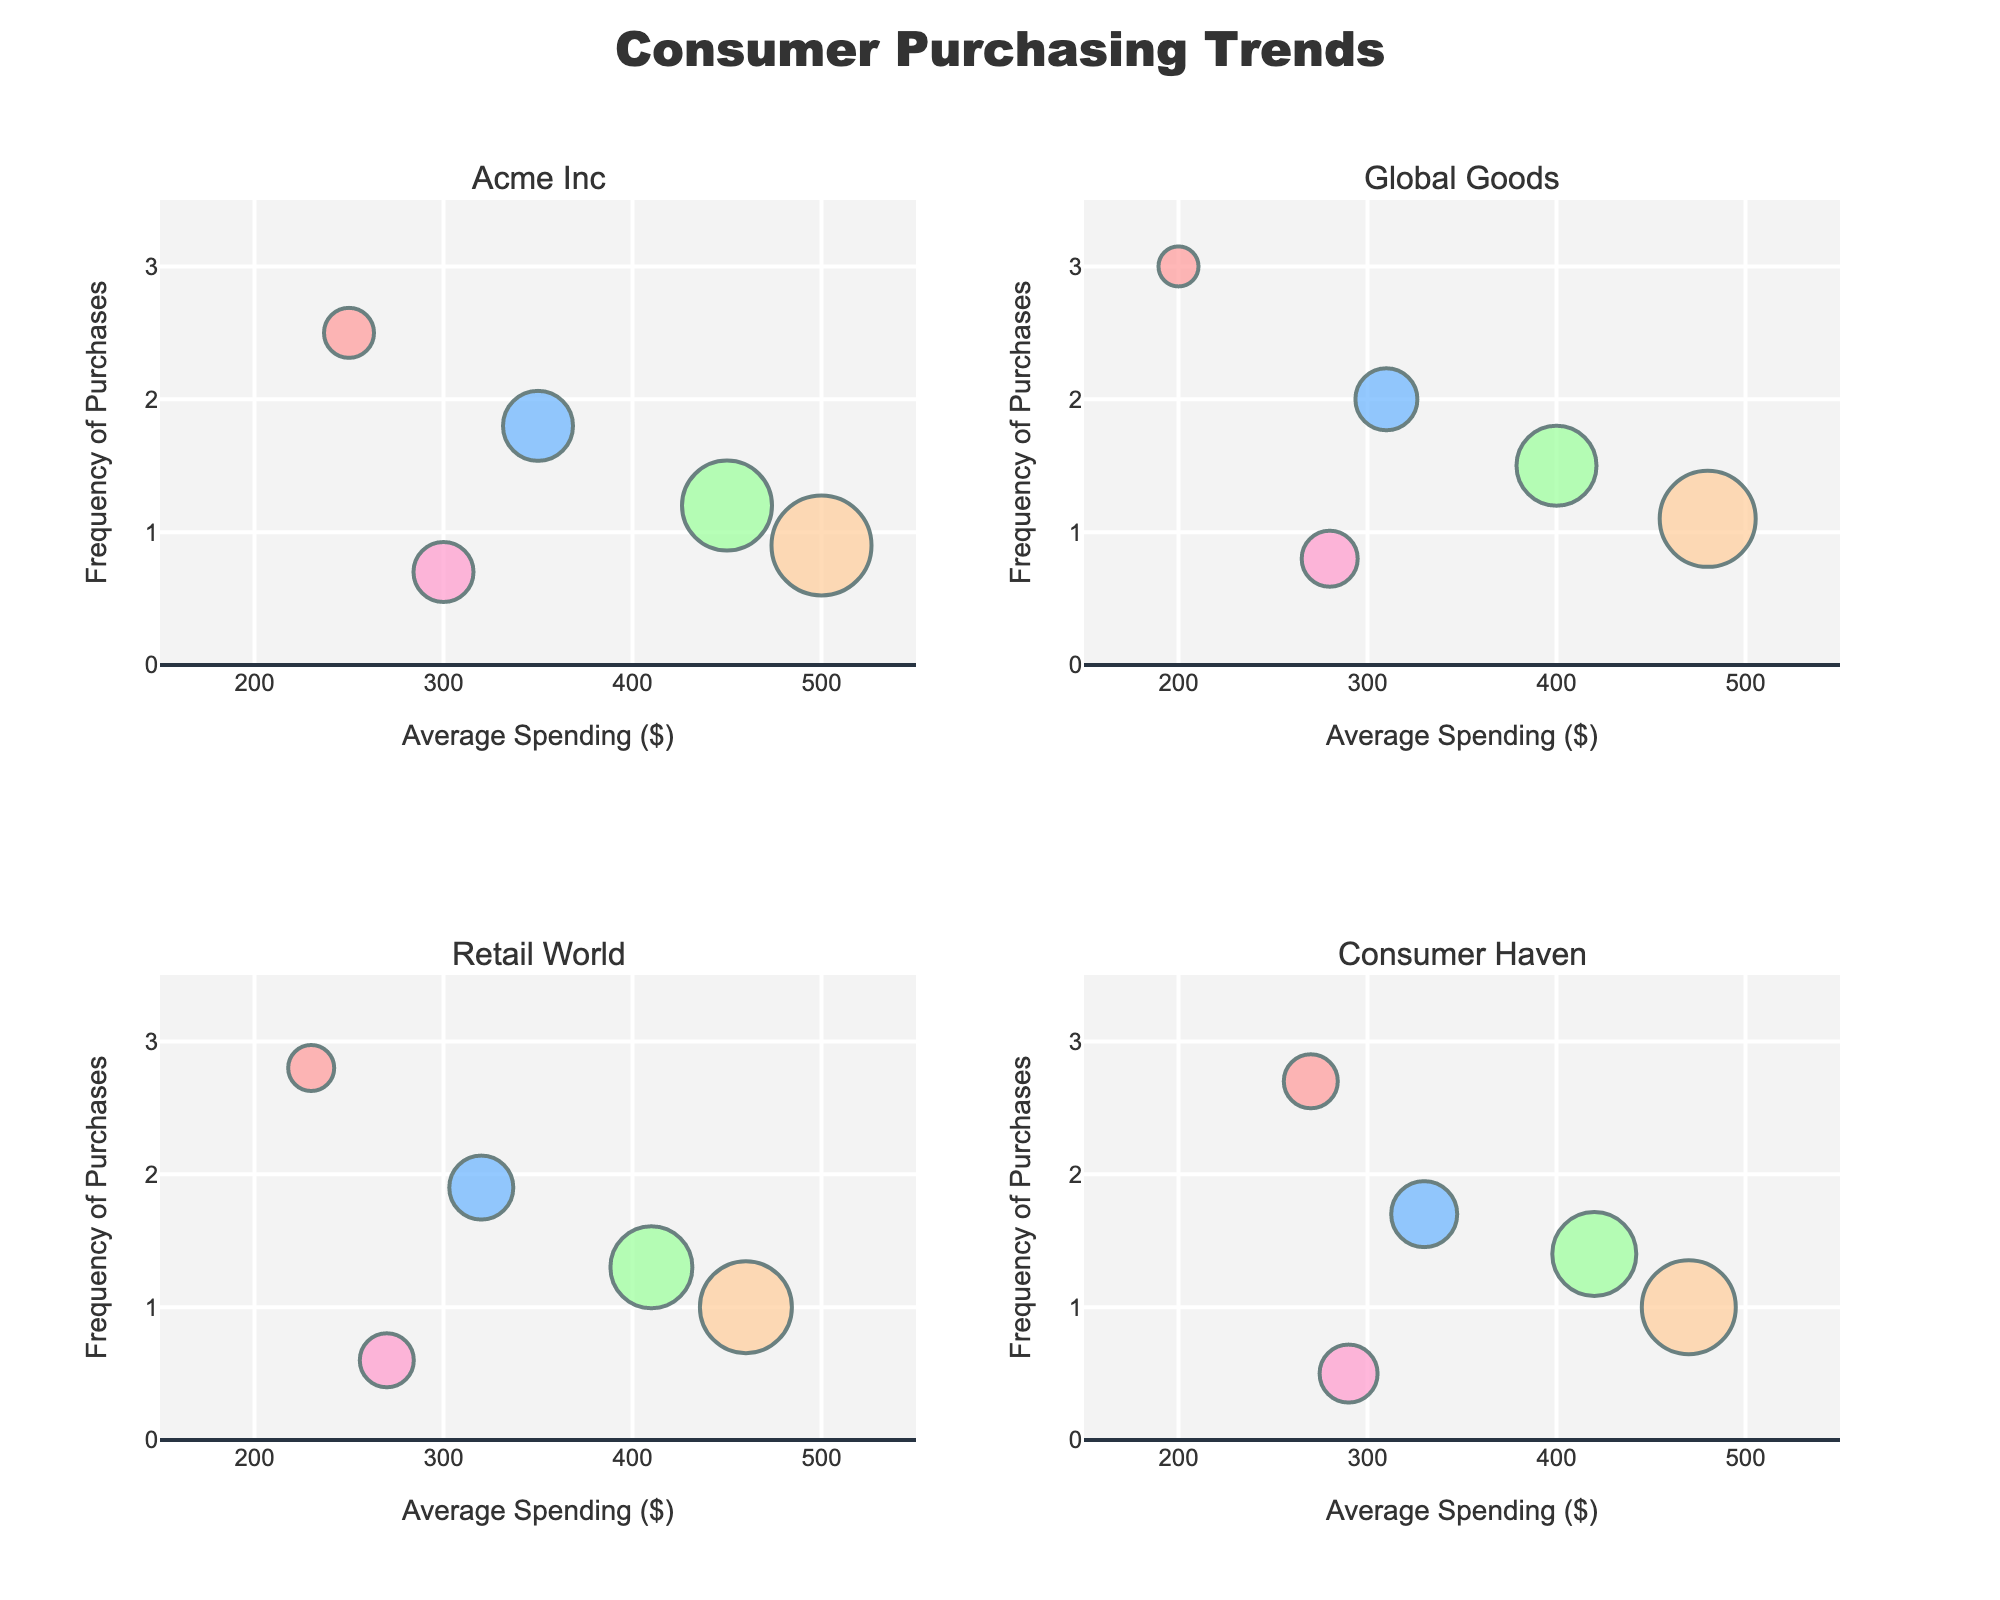How many subplots are in the figure? The figure contains 4 subplots, each representing a different brand's consumer purchasing trends.
Answer: 4 What is the title of the figure? The title is located at the top center of the figure. It reads "Consumer Purchasing Trends".
Answer: Consumer Purchasing Trends Which brand's subplot shows the highest average spending? By examining the subplots, the highest average spending is in the subplot for Acme Inc, where it goes up to 500 dollars for the 46-60 age group.
Answer: Acme Inc For the brand Global Goods, what is the frequency of purchases for the age group 18-25? In the subplot for Global Goods, the bubble representing the 18-25 age group shows a frequency of purchases of 3.0.
Answer: 3.0 In the subplot for Retail World, which age group shows the highest frequency of purchases? The largest bubble in terms of frequency for Retail World is for the age group 18-25, with a frequency of 2.8.
Answer: 18-25 Compare the average spending for the age group 36-45 between Acme Inc and Consumer Haven. Which brand has a higher average spending? By comparing the bubbles for the age group 36-45, Acme Inc has an average spending of 450 while Consumer Haven has 420. Thus, Acme Inc has higher average spending.
Answer: Acme Inc Which brand has the most consistent frequency of purchases across all age groups? By reviewing the frequency of purchases across all age groups in each subplot, Acme Inc has the most consistent frequency, with values ranging from 0.7 to 2.5.
Answer: Acme Inc Identify the age group with the lowest frequency of purchases for Consumer Haven. What is that frequency? The subplot for Consumer Haven shows that the age group 60+ has the lowest frequency of purchases at 0.5.
Answer: 60+, 0.5 What is the color used for the age group 26-35 in the bubble charts? Each bubble corresponding to the age group 26-35 is colored using different colors defined in the predefined custom color scale.
Answer: #66B2FF What is the range of average spending displayed on the x-axis? The x-axis for average spending ranges from 150 to 550 dollars.
Answer: 150-550 